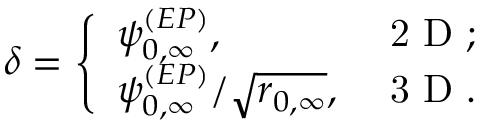Convert formula to latex. <formula><loc_0><loc_0><loc_500><loc_500>\delta = \left \{ \begin{array} { l l } { \psi _ { 0 , \infty } ^ { ( E P ) } , } & { 2 D ; } \\ { \psi _ { 0 , \infty } ^ { ( E P ) } / \sqrt { r _ { 0 , \infty } } , } & { 3 D . } \end{array}</formula> 